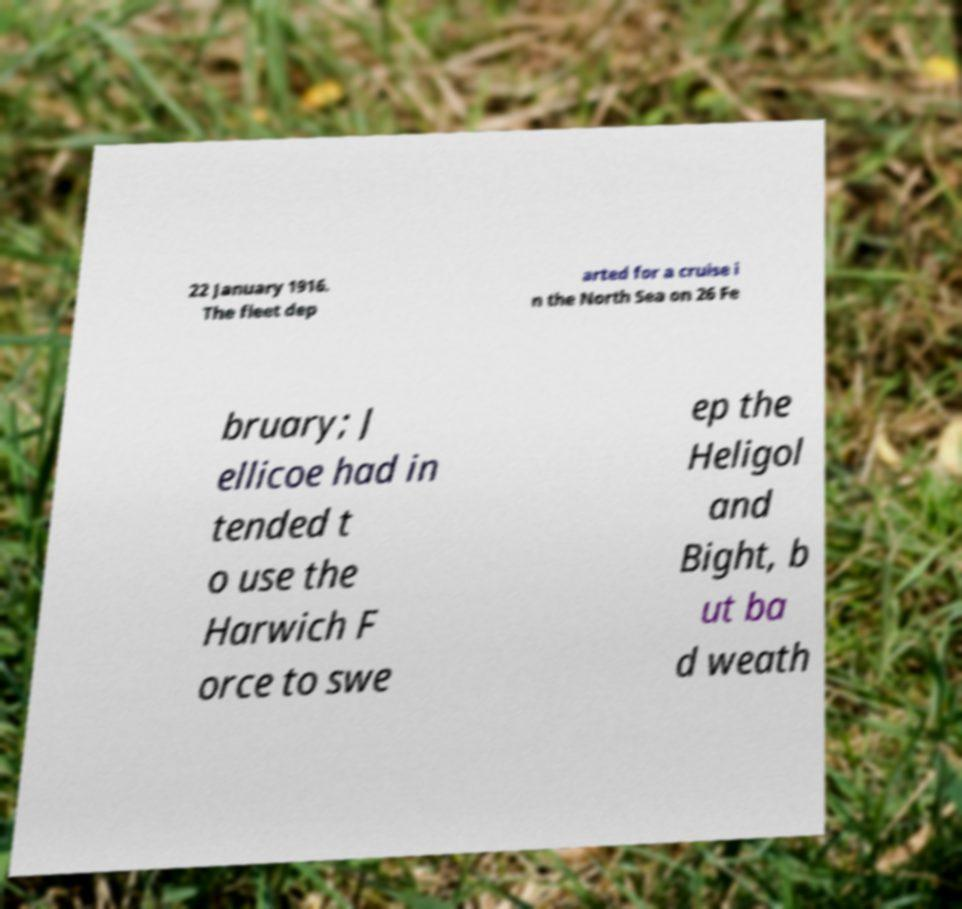Please read and relay the text visible in this image. What does it say? 22 January 1916. The fleet dep arted for a cruise i n the North Sea on 26 Fe bruary; J ellicoe had in tended t o use the Harwich F orce to swe ep the Heligol and Bight, b ut ba d weath 